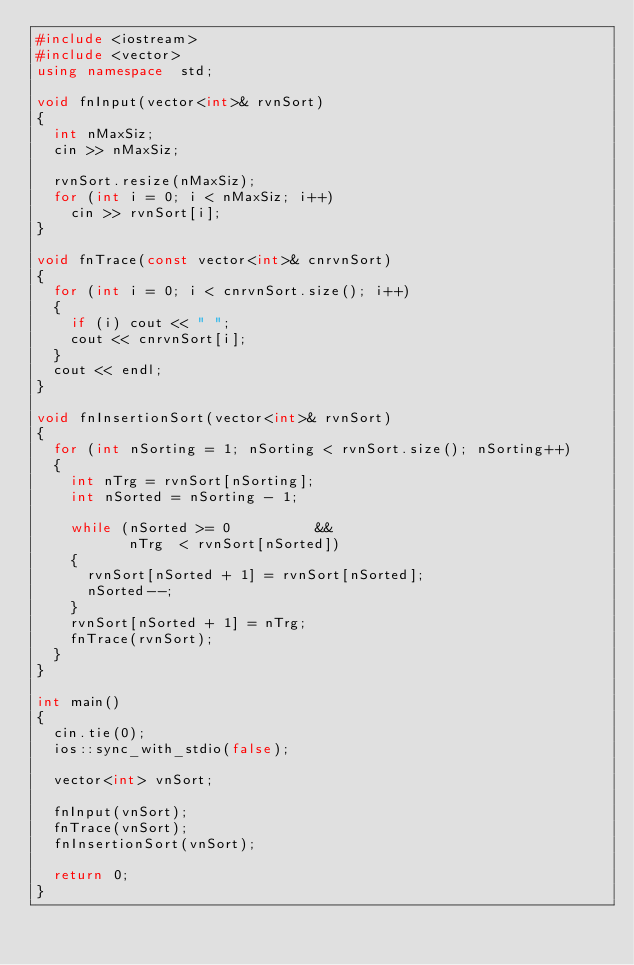<code> <loc_0><loc_0><loc_500><loc_500><_C++_>#include <iostream>
#include <vector>
using namespace  std;

void fnInput(vector<int>& rvnSort)
{
  int nMaxSiz;
  cin >> nMaxSiz;

  rvnSort.resize(nMaxSiz);
  for (int i = 0; i < nMaxSiz; i++)
    cin >> rvnSort[i];
} 

void fnTrace(const vector<int>& cnrvnSort)
{
  for (int i = 0; i < cnrvnSort.size(); i++)
  {
    if (i) cout << " ";
    cout << cnrvnSort[i];
  }
  cout << endl;
}

void fnInsertionSort(vector<int>& rvnSort)
{
  for (int nSorting = 1; nSorting < rvnSort.size(); nSorting++)
  {
    int nTrg = rvnSort[nSorting];
    int nSorted = nSorting - 1;

    while (nSorted >= 0          &&
           nTrg  < rvnSort[nSorted])
    {
      rvnSort[nSorted + 1] = rvnSort[nSorted];
      nSorted--;
    }
    rvnSort[nSorted + 1] = nTrg;
    fnTrace(rvnSort);
  }
}

int main()
{
  cin.tie(0);
  ios::sync_with_stdio(false);

  vector<int> vnSort;

  fnInput(vnSort);
  fnTrace(vnSort);
  fnInsertionSort(vnSort);

  return 0;
}</code> 